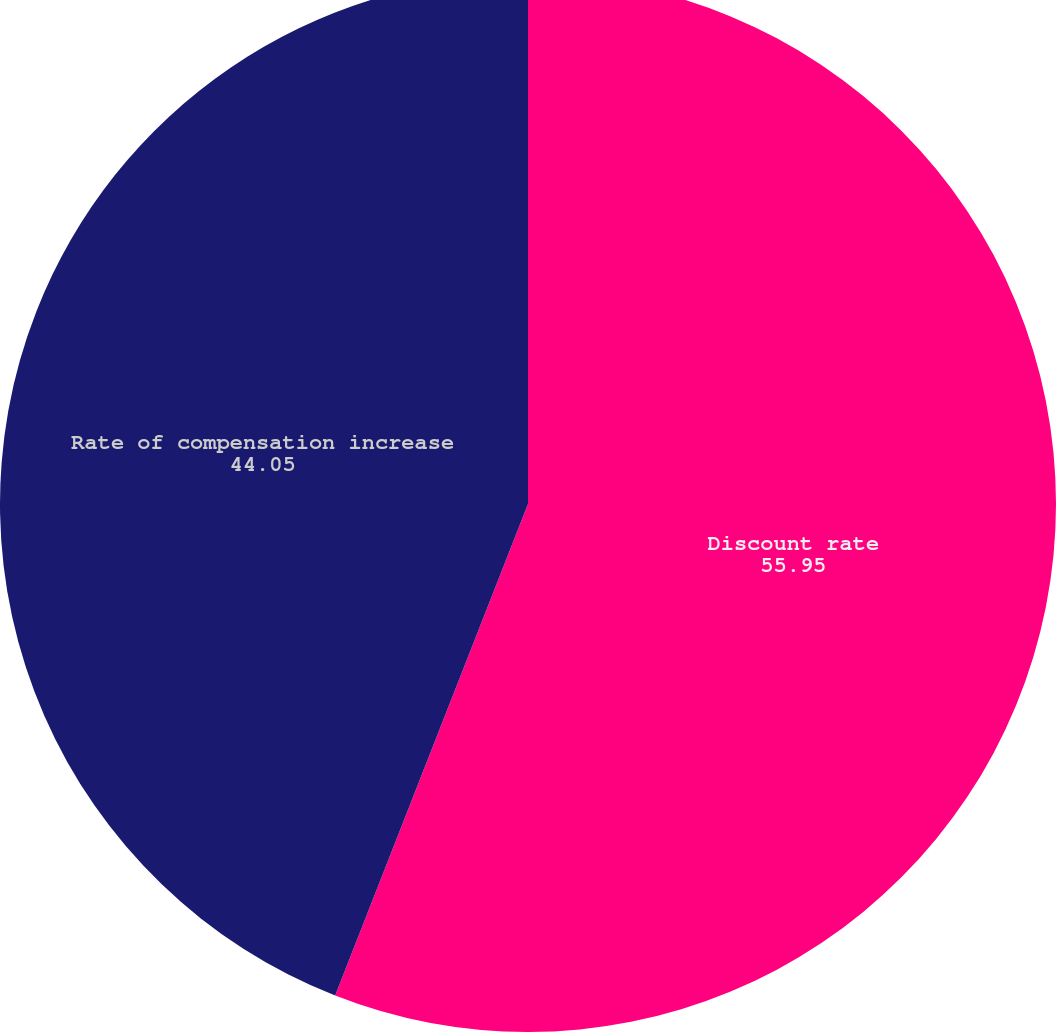Convert chart. <chart><loc_0><loc_0><loc_500><loc_500><pie_chart><fcel>Discount rate<fcel>Rate of compensation increase<nl><fcel>55.95%<fcel>44.05%<nl></chart> 